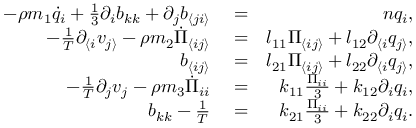<formula> <loc_0><loc_0><loc_500><loc_500>\begin{array} { r l r } { - \rho m _ { 1 } \dot { q } _ { i } + \frac { 1 } { 3 } \partial _ { i } b _ { k k } + \partial _ { j } b _ { \langle j i \rangle } } & = } & { n q _ { i } , } \\ { - \frac { 1 } { T } \partial _ { \langle i } v _ { j \rangle } - \rho m _ { 2 } \dot { \Pi } _ { \langle i j \rangle } } & = } & { l _ { 1 1 } \Pi _ { \langle i j \rangle } + l _ { 1 2 } \partial _ { \langle i } q _ { j \rangle } , } \\ { b _ { \langle i j \rangle } } & = } & { l _ { 2 1 } \Pi _ { \langle i j \rangle } + l _ { 2 2 } \partial _ { \langle i } q _ { j \rangle } , } \\ { - \frac { 1 } { T } \partial _ { j } v _ { j } - \rho m _ { 3 } \dot { \Pi } _ { i i } } & = } & { k _ { 1 1 } \frac { \Pi _ { i i } } { 3 } + k _ { 1 2 } \partial _ { i } q _ { i } , } \\ { b _ { k k } - \frac { 1 } { T } } & = } & { k _ { 2 1 } \frac { \Pi _ { i i } } { 3 } + k _ { 2 2 } \partial _ { i } q _ { i } . } \end{array}</formula> 